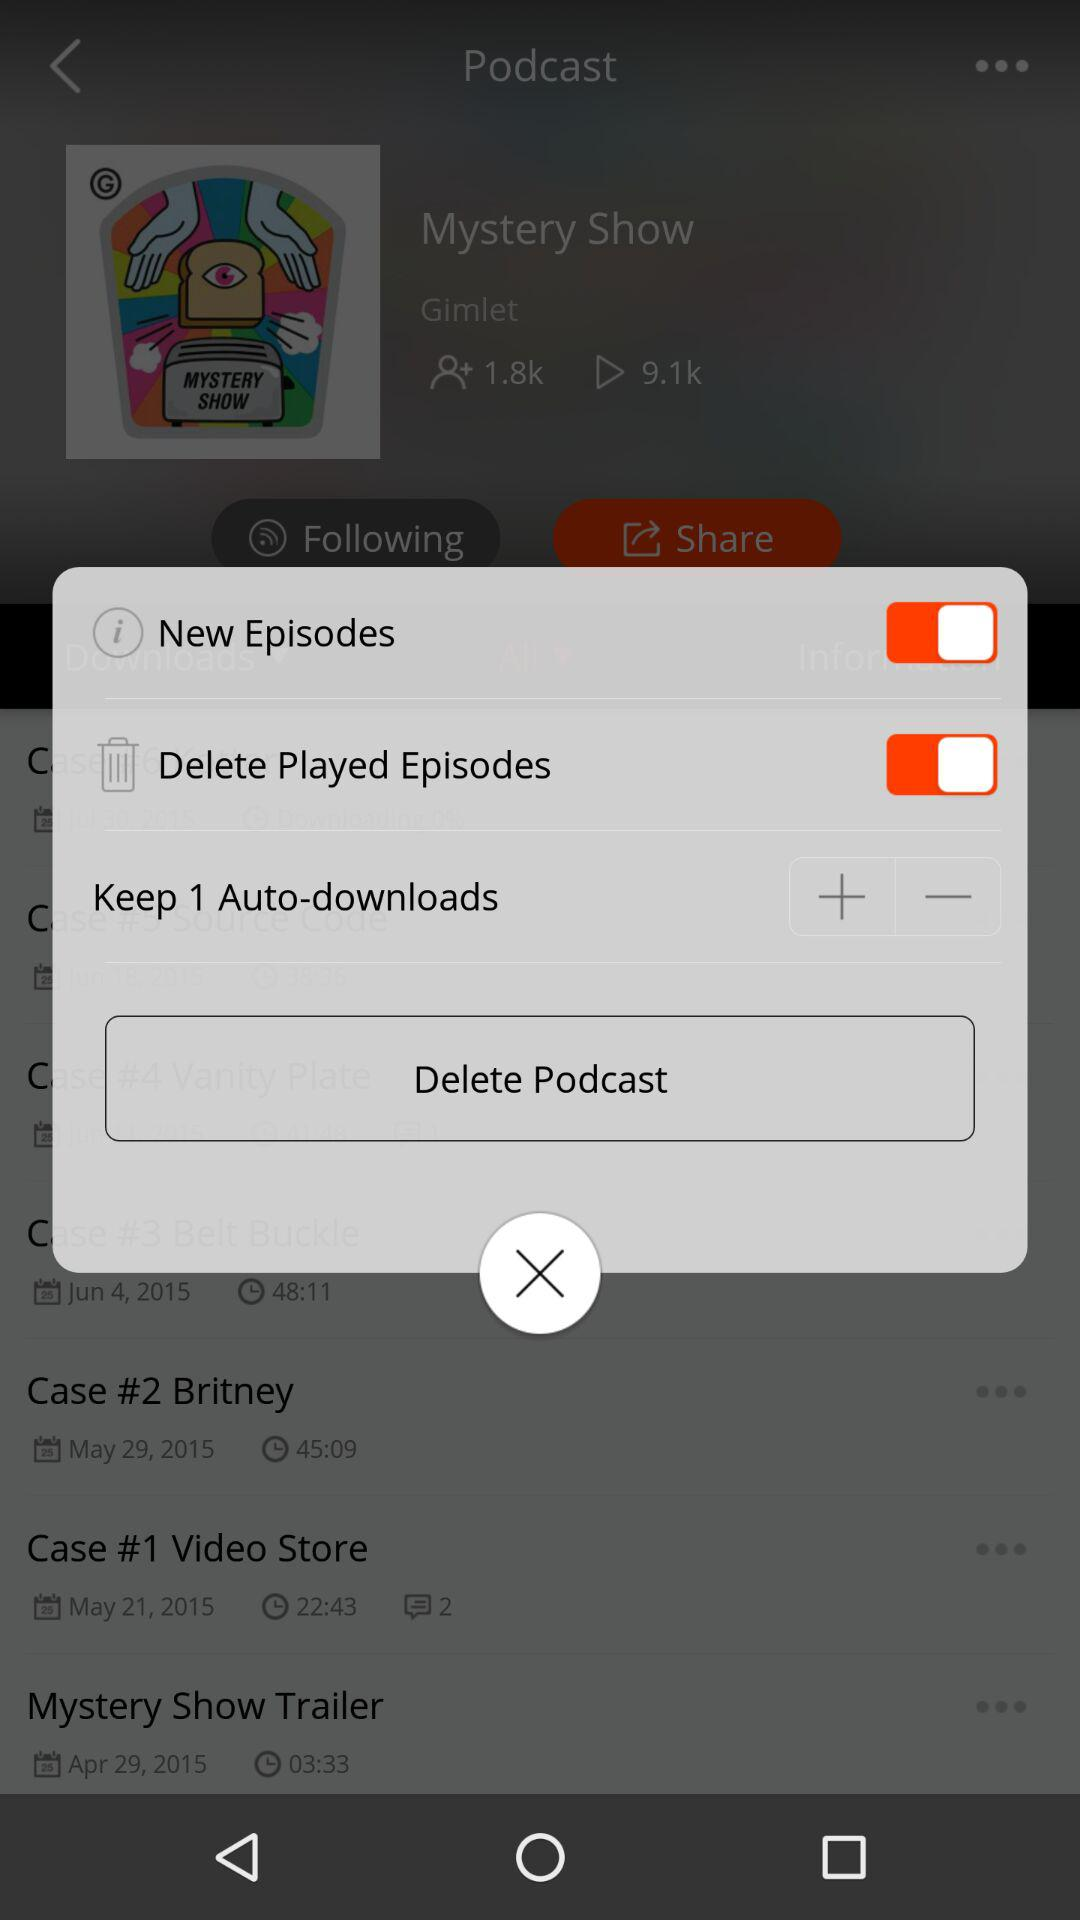How to delete played episodes?
When the provided information is insufficient, respond with <no answer>. <no answer> 